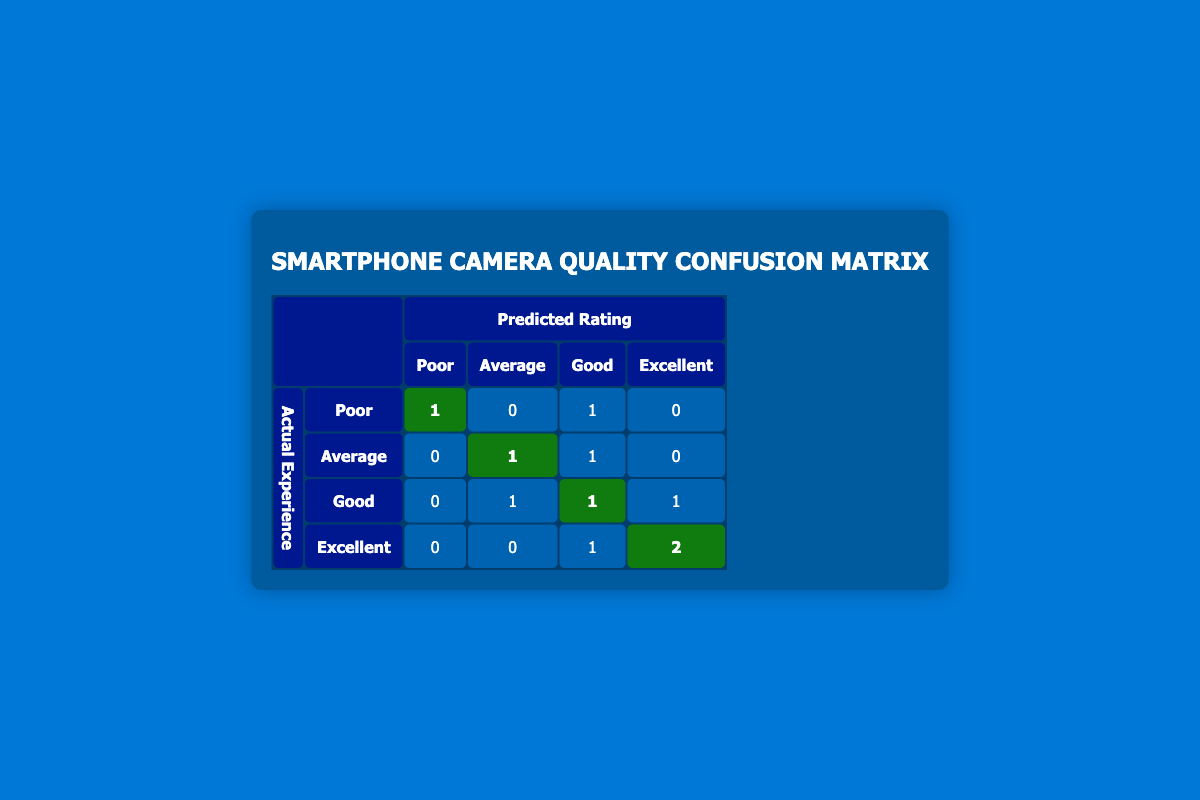What is the number of smartphones that were rated as "Poor" but actually had an "Excellent" user experience? In the table under the "Actual Experience" row for "Poor," we can see there are no areas highlighted with a number in the "Excellent" column. Therefore, the count is zero.
Answer: 0 How many smartphones were estimated to have "Excellent" ratings by users? In the "Actual Experience" row for "Excellent," there are two highlighted numbers in the "Excellent" column. Therefore, there are two smartphones estimated to have "Excellent" ratings by users.
Answer: 2 What is the total count of smartphones that had an "Average" predicted rating? By looking at the "Predicted Rating" row for "Average," we see three instances highlighted: one for "Actual Experience" as "Poor," one for "Good," and one for "Average." Thus, the total count is three.
Answer: 3 Is it true that all smartphones with "Excellent" predicted ratings also had an "Excellent" actual user experience? In reviewing the "Actual Experience" for those with "Excellent" predicted ratings, which are two cases, both had "Excellent" actual experiences highlighted. So yes, it is a true statement.
Answer: Yes What is the total number of smartphones that had "Good" predicted ratings but "Poor" actual experiences? In the "Predicted Rating" row for "Good," under the "Actual Experience" column for "Poor," there is one highlighted entry. Thus, the total number is one smartphone that fits this criterion.
Answer: 1 How many smartphones received an "Average" or "Good" predicted rating but had a "Poor" actual experience? From the table, we first check the "Actual Experience" row for "Poor." There is one highlighted smartphone with an "Average" predicted rating and one smartphone with a "Good" predicted rating; thus, there are two smartphones total.
Answer: 2 What percentage of smartphones had an "Excellent" actual user experience? There are a total of 10 smartphones; 3 of them had an "Excellent" actual experience. So, the percentage is (3/10)*100, which equals 30%.
Answer: 30% Which predicted rating had the highest mismatch between predicted and actual experiences? By observing the rows, we see the "Good" predicted rating misaligned the most with "Poor" and "Average" actual experiences, highlighting a total of four instances.
Answer: Good What is the relationship between predicted ratings and actual user experiences for the "Samsung Galaxy S4"? The Samsung Galaxy S4 is listed under "Predicted Rating" as "Good" and under "Actual Experience" as "Average." This signifies a mismatch where the predicted quality was higher than the actual experience.
Answer: Mismatch 